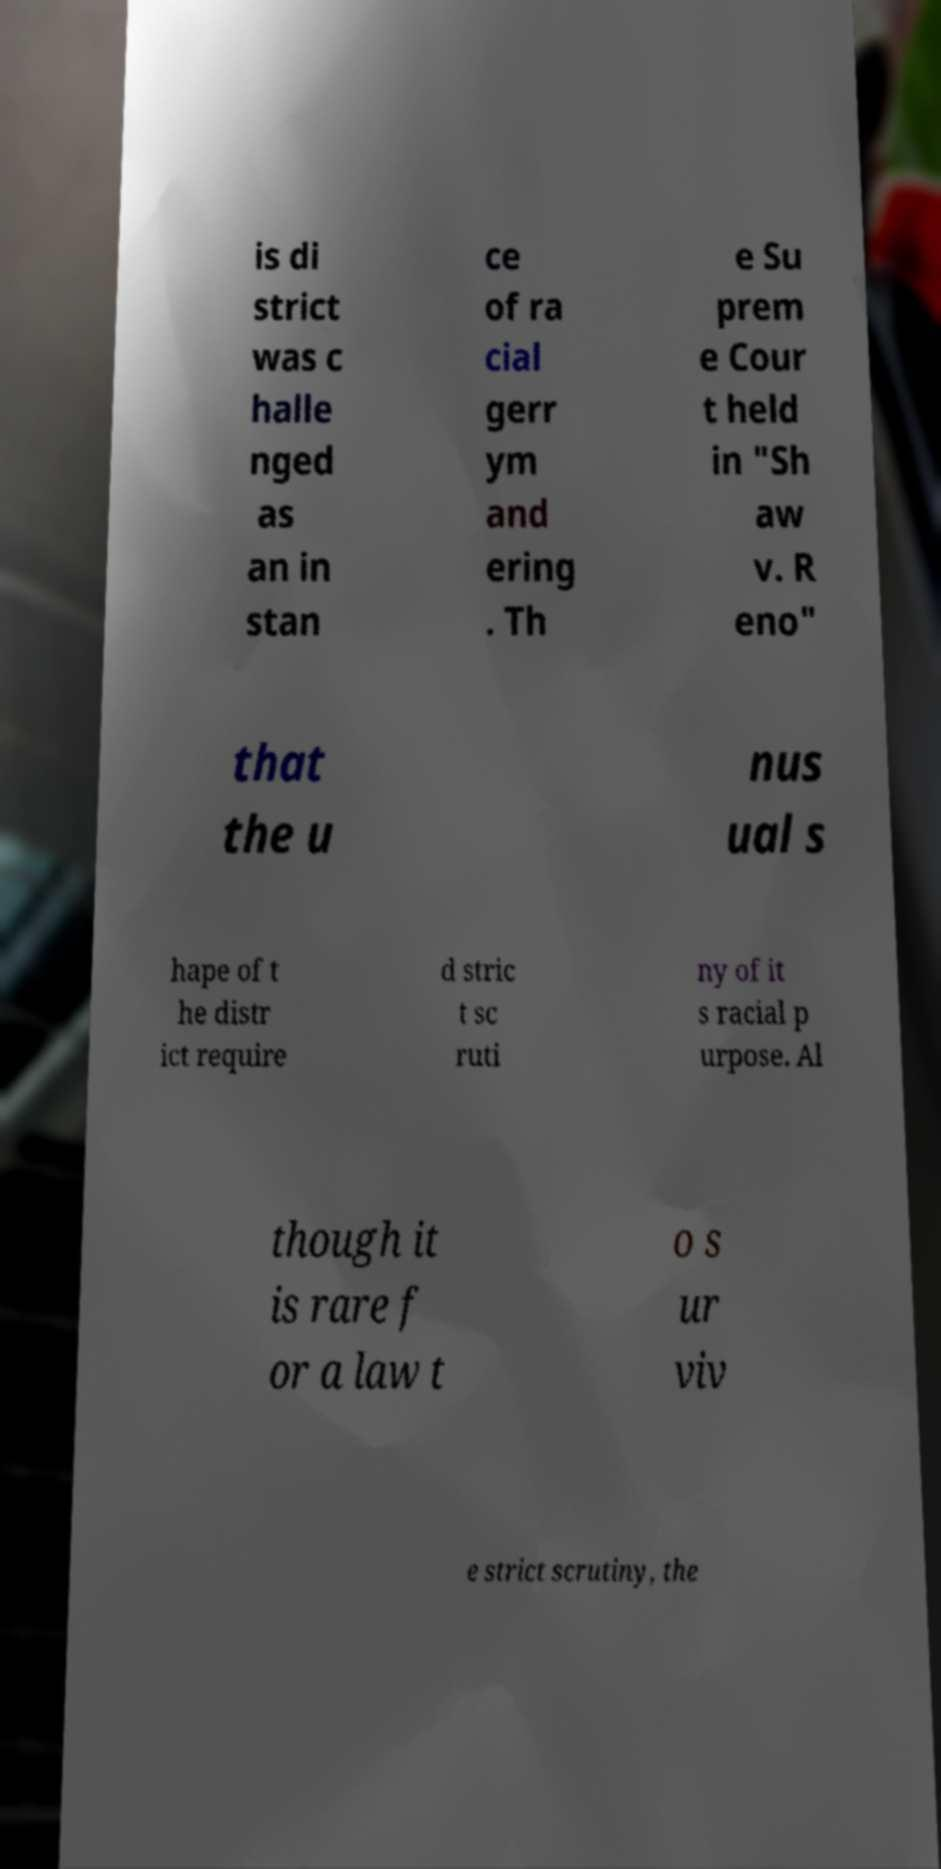What messages or text are displayed in this image? I need them in a readable, typed format. is di strict was c halle nged as an in stan ce of ra cial gerr ym and ering . Th e Su prem e Cour t held in "Sh aw v. R eno" that the u nus ual s hape of t he distr ict require d stric t sc ruti ny of it s racial p urpose. Al though it is rare f or a law t o s ur viv e strict scrutiny, the 